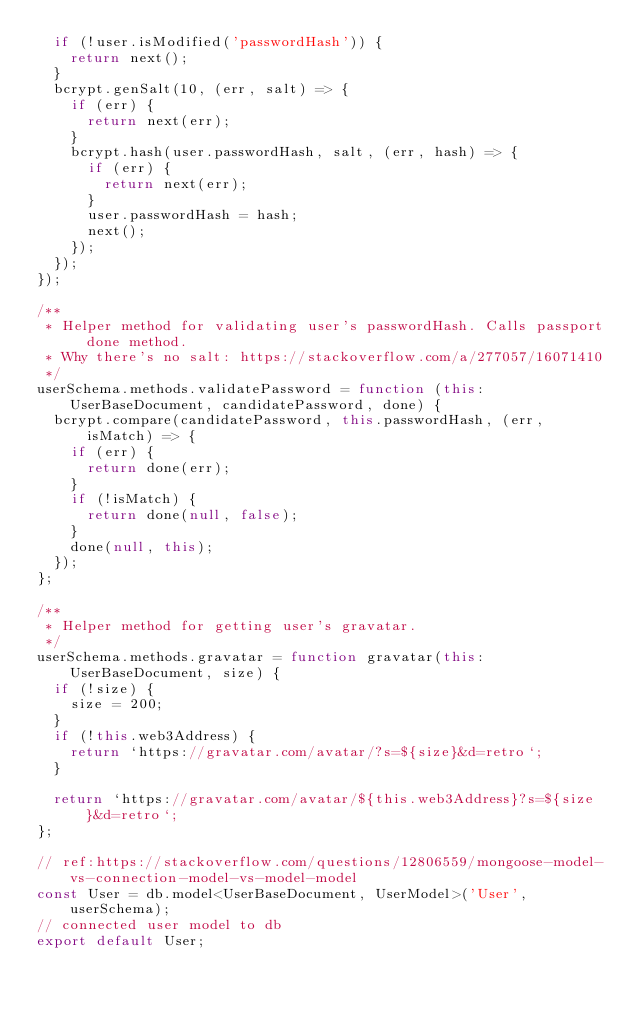Convert code to text. <code><loc_0><loc_0><loc_500><loc_500><_TypeScript_>  if (!user.isModified('passwordHash')) {
    return next();
  }
  bcrypt.genSalt(10, (err, salt) => {
    if (err) {
      return next(err);
    }
    bcrypt.hash(user.passwordHash, salt, (err, hash) => {
      if (err) {
        return next(err);
      }
      user.passwordHash = hash;
      next();
    });
  });
});

/**
 * Helper method for validating user's passwordHash. Calls passport done method.
 * Why there's no salt: https://stackoverflow.com/a/277057/16071410
 */
userSchema.methods.validatePassword = function (this: UserBaseDocument, candidatePassword, done) {
  bcrypt.compare(candidatePassword, this.passwordHash, (err, isMatch) => {
    if (err) {
      return done(err);
    }
    if (!isMatch) {
      return done(null, false);
    }
    done(null, this);
  });
};

/**
 * Helper method for getting user's gravatar.
 */
userSchema.methods.gravatar = function gravatar(this: UserBaseDocument, size) {
  if (!size) {
    size = 200;
  }
  if (!this.web3Address) {
    return `https://gravatar.com/avatar/?s=${size}&d=retro`;
  }

  return `https://gravatar.com/avatar/${this.web3Address}?s=${size}&d=retro`;
};

// ref:https://stackoverflow.com/questions/12806559/mongoose-model-vs-connection-model-vs-model-model
const User = db.model<UserBaseDocument, UserModel>('User', userSchema);
// connected user model to db
export default User;
</code> 